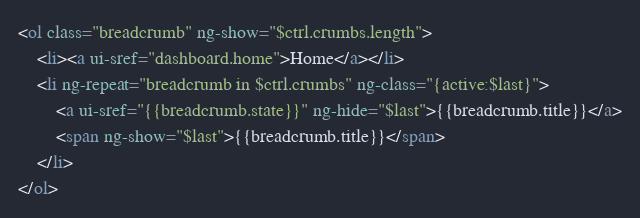<code> <loc_0><loc_0><loc_500><loc_500><_HTML_><ol class="breadcrumb" ng-show="$ctrl.crumbs.length">
	<li><a ui-sref="dashboard.home">Home</a></li>
	<li ng-repeat="breadcrumb in $ctrl.crumbs" ng-class="{active:$last}">
		<a ui-sref="{{breadcrumb.state}}" ng-hide="$last">{{breadcrumb.title}}</a>
		<span ng-show="$last">{{breadcrumb.title}}</span>
	</li>
</ol></code> 